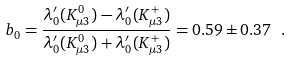Convert formula to latex. <formula><loc_0><loc_0><loc_500><loc_500>b _ { 0 } = \frac { \lambda ^ { \prime } _ { 0 } ( K ^ { 0 } _ { \mu 3 } ) - \lambda ^ { \prime } _ { 0 } ( K ^ { + } _ { \mu 3 } ) } { \lambda ^ { \prime } _ { 0 } ( K ^ { 0 } _ { \mu 3 } ) + \lambda ^ { \prime } _ { 0 } ( K ^ { + } _ { \mu 3 } ) } = 0 . 5 9 \pm 0 . 3 7 \ .</formula> 